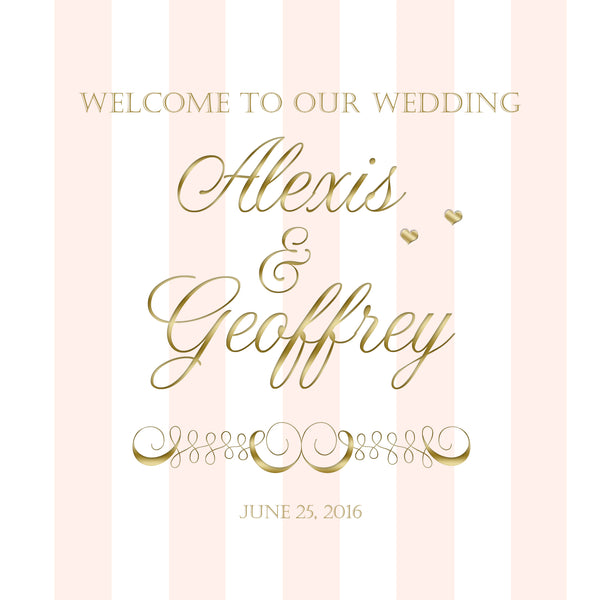If a specific song were to symbolize this wedding based on the invitation, what might it be and why? A song that might symbolize this wedding based on the invitation could be 'Can't Help Falling in Love' by Elvis Presley. This timeless song is both classic and romantic, matching the elegant feel of the gold and pink invitation. Its gentle melody and heartfelt lyrics perfectly capture the love and sophistication suggested by the wedding theme. 